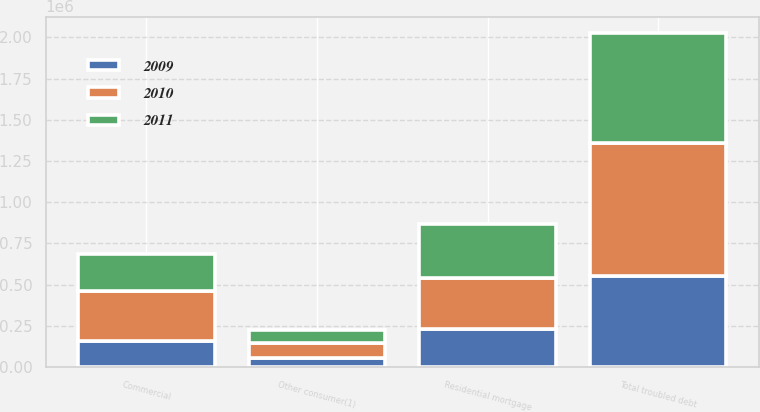<chart> <loc_0><loc_0><loc_500><loc_500><stacked_bar_chart><ecel><fcel>Residential mortgage<fcel>Other consumer(1)<fcel>Commercial<fcel>Total troubled debt<nl><fcel>2010<fcel>309678<fcel>94905<fcel>303975<fcel>805650<nl><fcel>2011<fcel>328411<fcel>76586<fcel>222632<fcel>666880<nl><fcel>2009<fcel>229470<fcel>52871<fcel>157049<fcel>552836<nl></chart> 